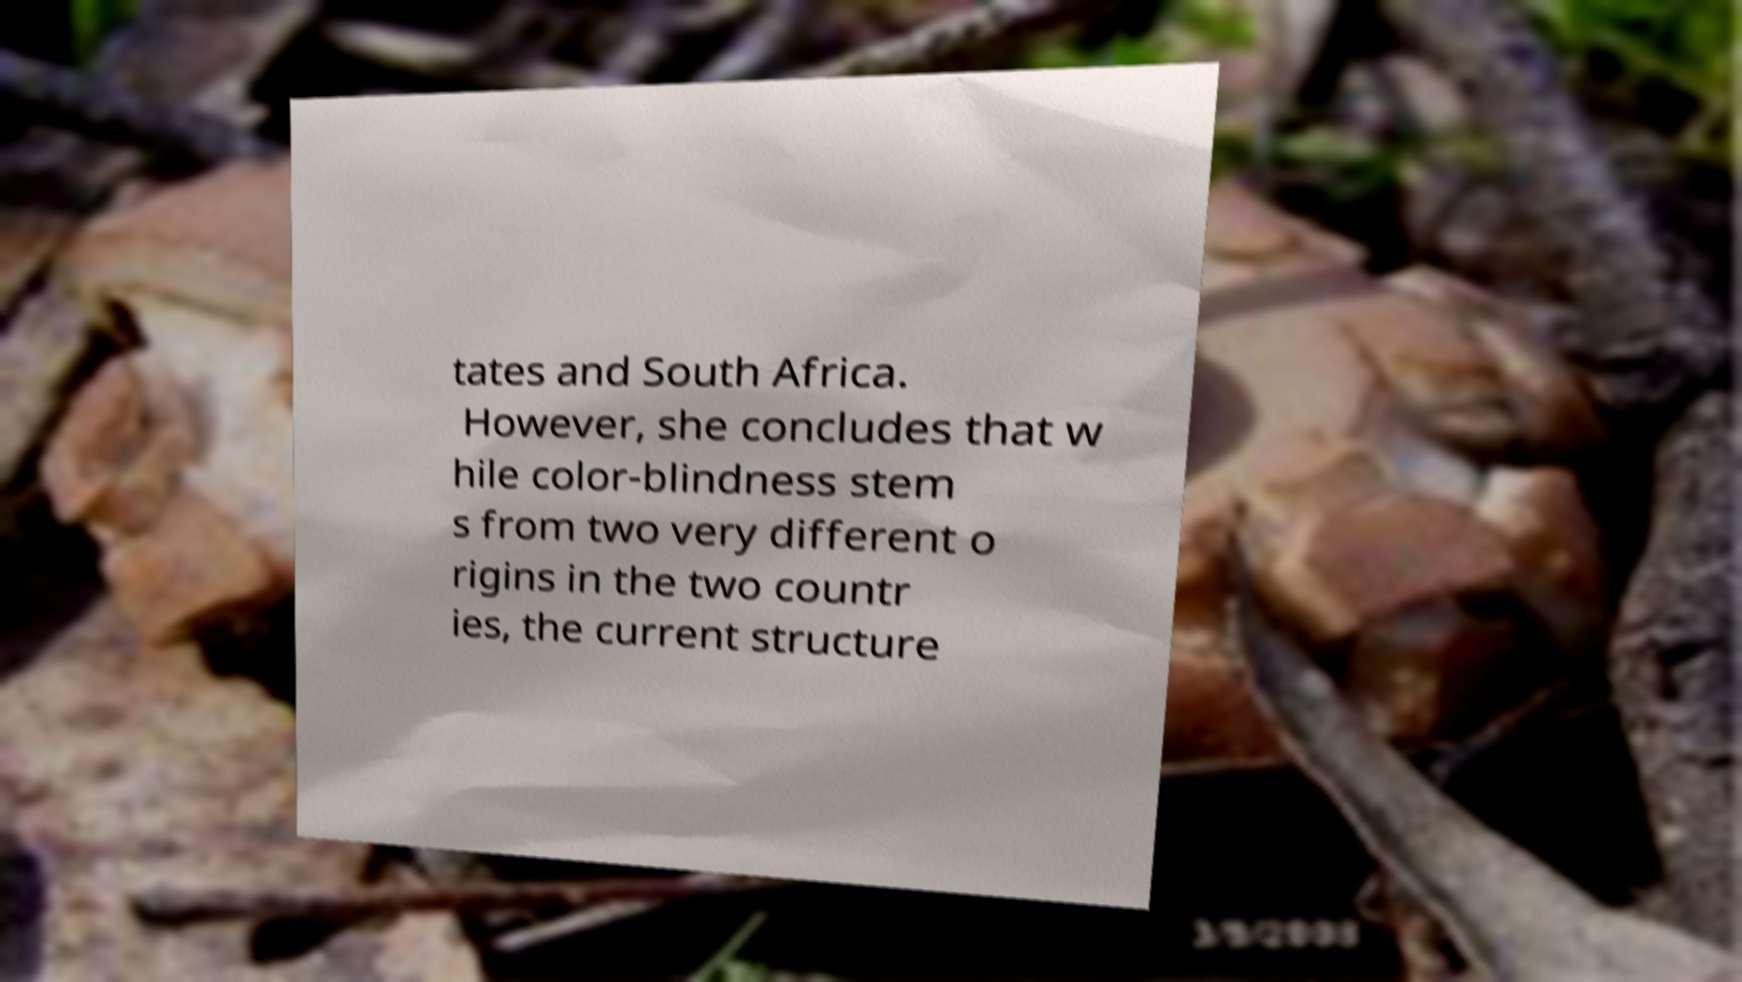What messages or text are displayed in this image? I need them in a readable, typed format. tates and South Africa. However, she concludes that w hile color-blindness stem s from two very different o rigins in the two countr ies, the current structure 